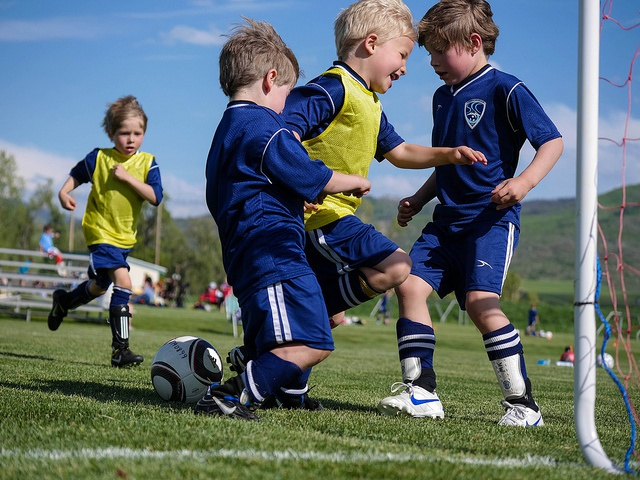Describe the objects in this image and their specific colors. I can see people in gray, black, navy, lightpink, and lightgray tones, people in gray, black, navy, darkblue, and blue tones, people in gray, black, navy, tan, and olive tones, people in gray, black, olive, and navy tones, and sports ball in gray, black, and purple tones in this image. 